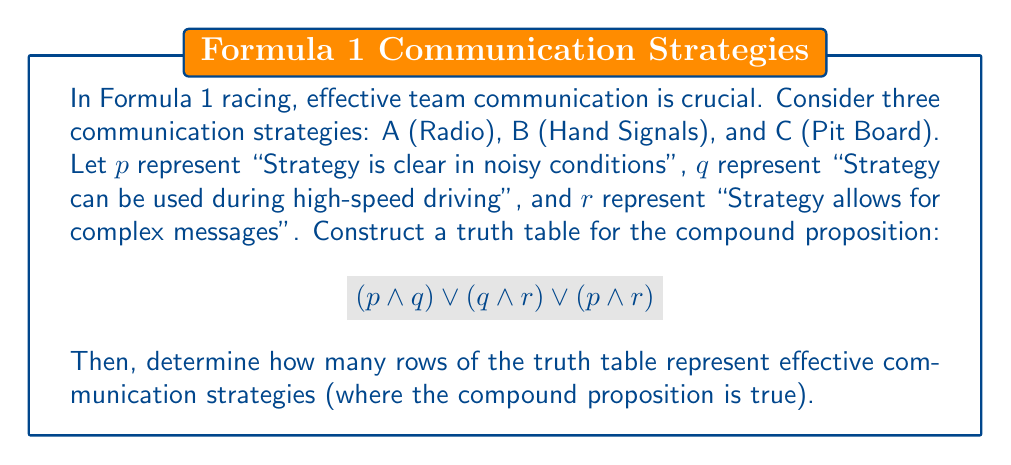Show me your answer to this math problem. Let's approach this step-by-step:

1) First, we need to construct the truth table. We have three variables (p, q, r), so our truth table will have $2^3 = 8$ rows.

2) Let's create the truth table:

   | p | q | r | p ∧ q | q ∧ r | p ∧ r | (p ∧ q) ∨ (q ∧ r) ∨ (p ∧ r) |
   |---|---|---|-------|-------|-------|--------------------------------|
   | T | T | T |   T   |   T   |   T   |               T                |
   | T | T | F |   T   |   F   |   F   |               T                |
   | T | F | T |   F   |   F   |   T   |               T                |
   | T | F | F |   F   |   F   |   F   |               F                |
   | F | T | T |   F   |   T   |   F   |               T                |
   | F | T | F |   F   |   F   |   F   |               F                |
   | F | F | T |   F   |   F   |   F   |               F                |
   | F | F | F |   F   |   F   |   F   |               F                |

3) Now, we need to count how many rows have a 'T' in the final column. This represents the number of scenarios where at least one pair of conditions is met, indicating an effective communication strategy.

4) Counting the 'T's in the final column, we get 4.

Therefore, there are 4 rows in the truth table that represent effective communication strategies.
Answer: 4 